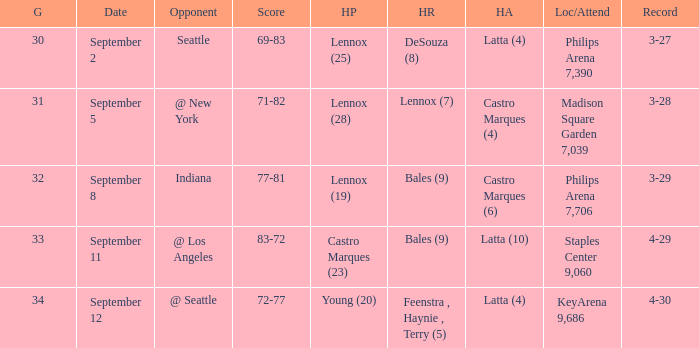Which Location/Attendance has High rebounds of lennox (7)? Madison Square Garden 7,039. 